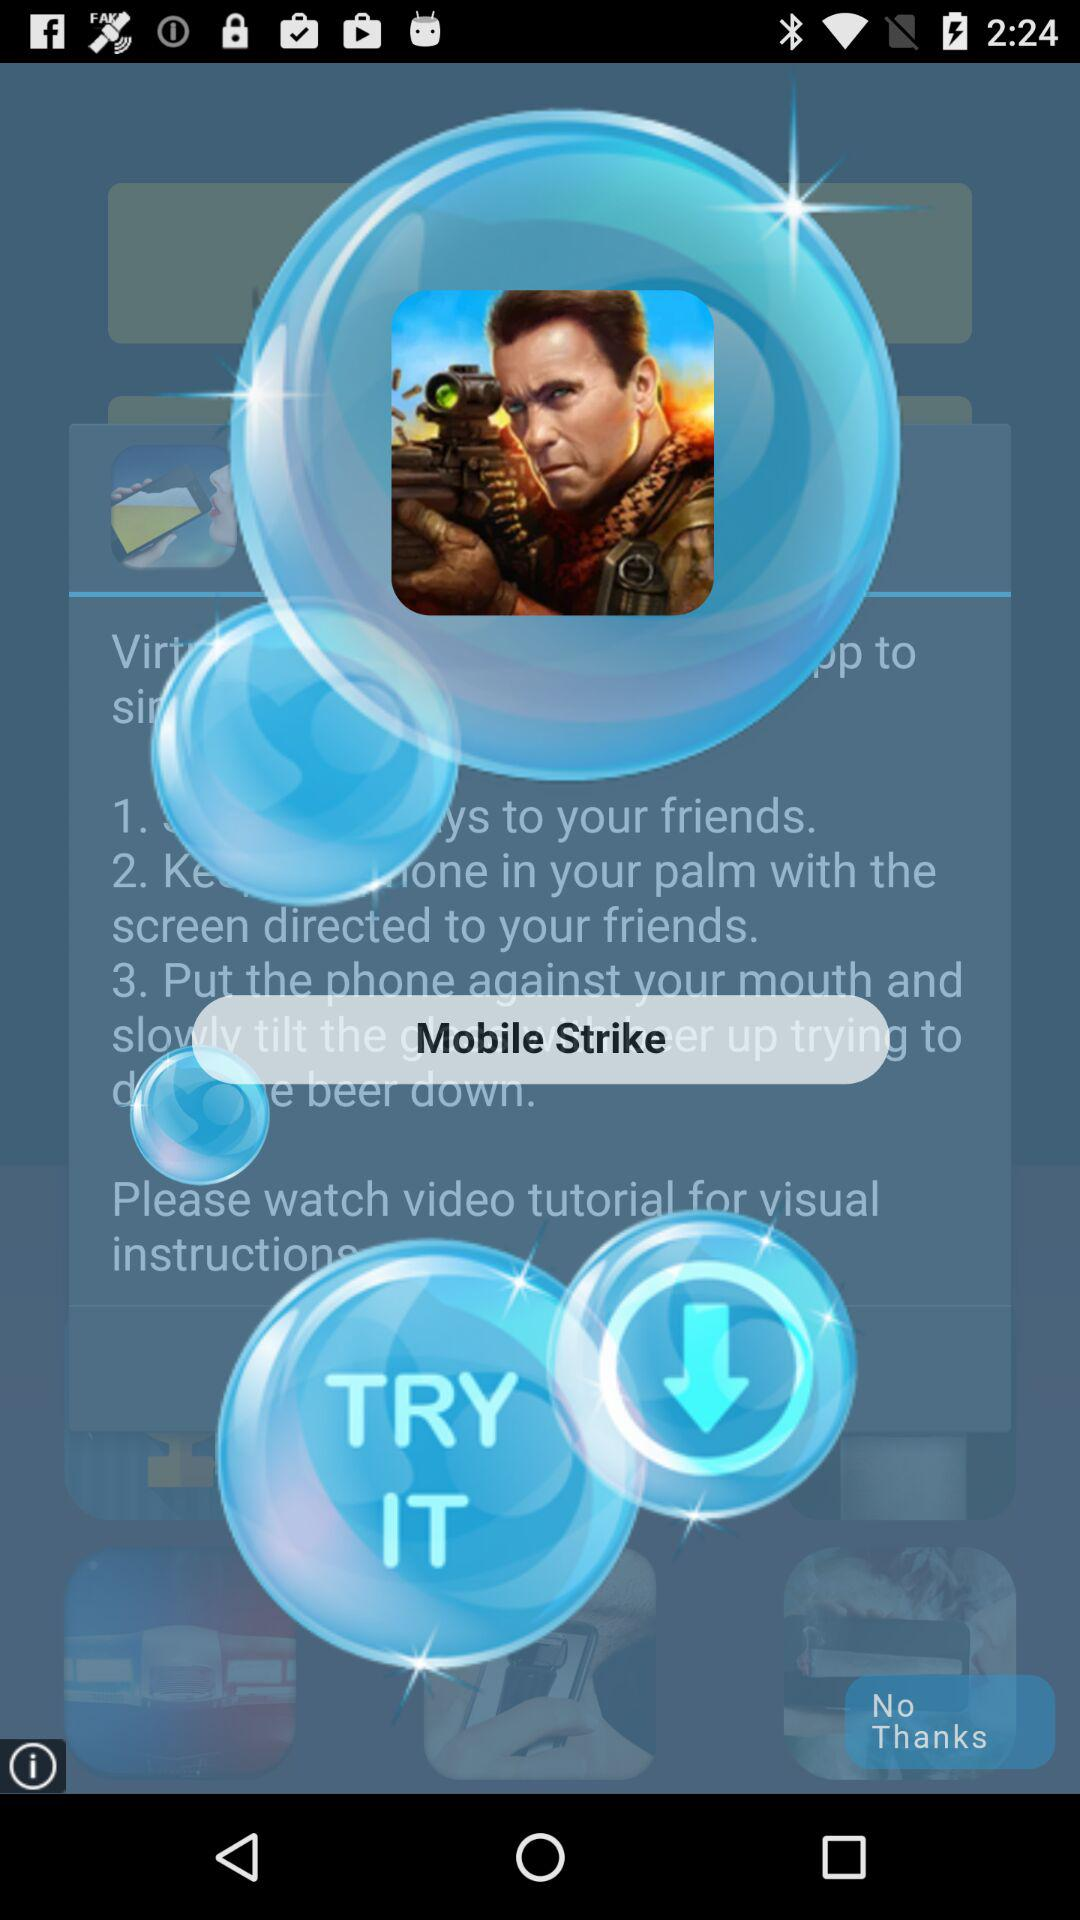How many instructions are there in the instructions for how to play the game?
Answer the question using a single word or phrase. 3 